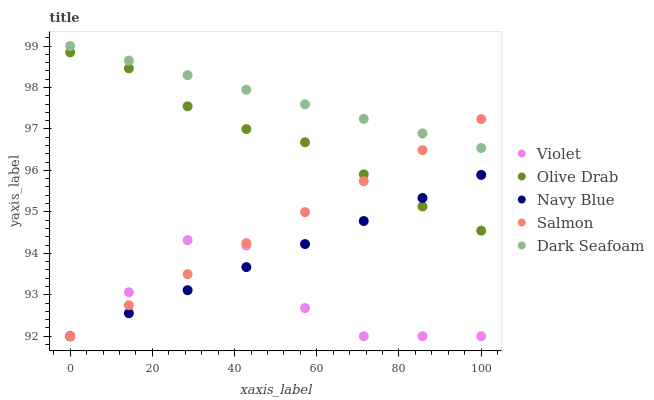Does Violet have the minimum area under the curve?
Answer yes or no. Yes. Does Dark Seafoam have the maximum area under the curve?
Answer yes or no. Yes. Does Salmon have the minimum area under the curve?
Answer yes or no. No. Does Salmon have the maximum area under the curve?
Answer yes or no. No. Is Salmon the smoothest?
Answer yes or no. Yes. Is Violet the roughest?
Answer yes or no. Yes. Is Dark Seafoam the smoothest?
Answer yes or no. No. Is Dark Seafoam the roughest?
Answer yes or no. No. Does Navy Blue have the lowest value?
Answer yes or no. Yes. Does Dark Seafoam have the lowest value?
Answer yes or no. No. Does Dark Seafoam have the highest value?
Answer yes or no. Yes. Does Salmon have the highest value?
Answer yes or no. No. Is Navy Blue less than Dark Seafoam?
Answer yes or no. Yes. Is Dark Seafoam greater than Navy Blue?
Answer yes or no. Yes. Does Salmon intersect Olive Drab?
Answer yes or no. Yes. Is Salmon less than Olive Drab?
Answer yes or no. No. Is Salmon greater than Olive Drab?
Answer yes or no. No. Does Navy Blue intersect Dark Seafoam?
Answer yes or no. No. 